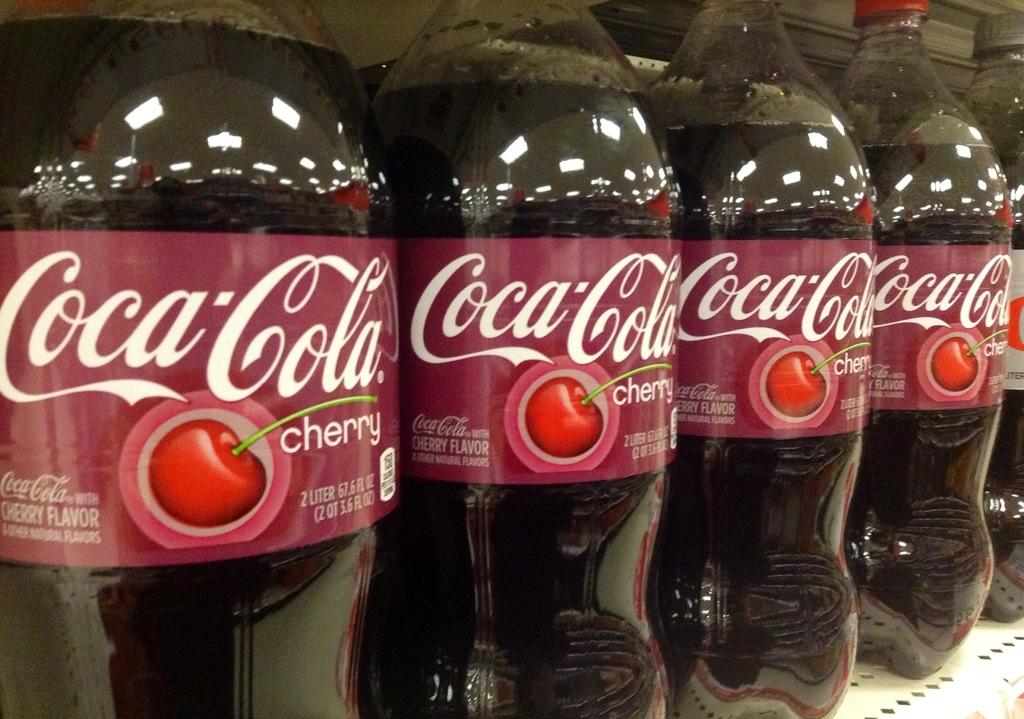How many Coca-Cola bottles are visible in the image? There are five Coca-Cola bottles in the image. What is attached to each bottle? Each bottle has a sticker attached. Where are the bottles located in the image? The bottles are placed on a shelf. Can you tell me how much each bottle weighs on a scale in the image? There is no scale present in the image, so it is not possible to determine the weight of the bottles. 